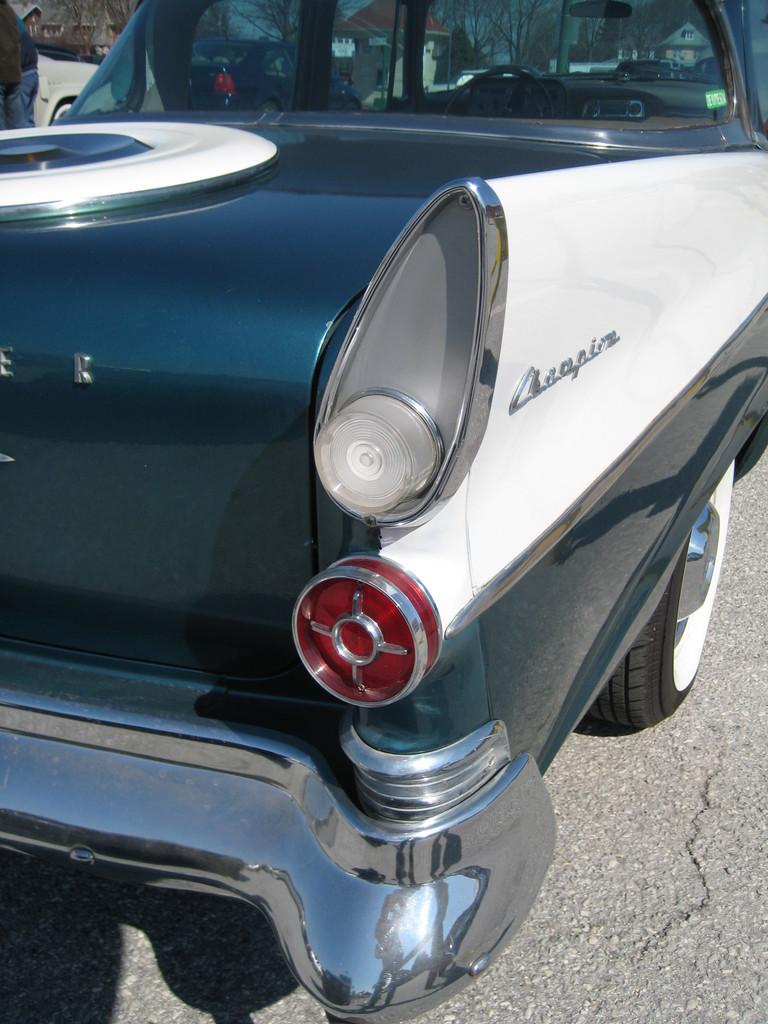What is the main subject of the image? The main subject of the image is a car. Can you describe the car in the image? The car is in the center of the image and has text written on it. What colors are used for the text on the car? The text on the car is white and black in color. How many birds can be seen flying over the car in the image? There are no birds visible in the image; it only features a car with text on it. 